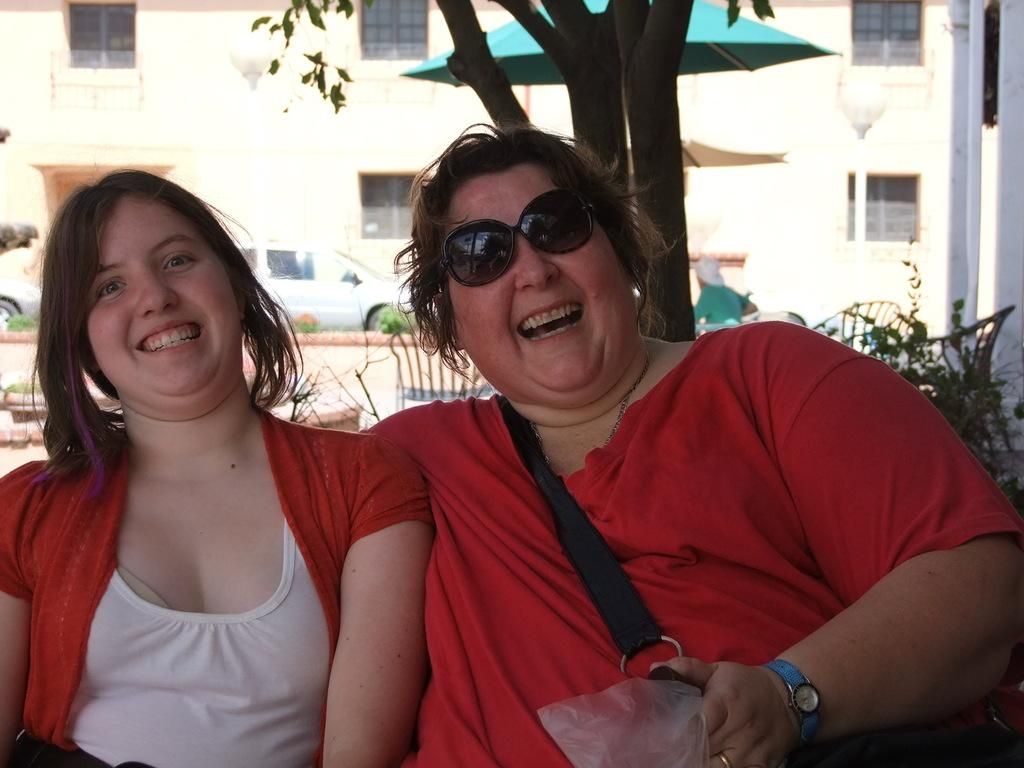Who are the main subjects in the image? There are two ladies in the center of the image. What can be seen at the top side of the image? There is a building and a tree at the top side of the image. What type of oatmeal is being served under the tree in the image? There is no oatmeal or any food item present in the image. What news is being discussed by the ladies in the image? There is no indication of a conversation or news being discussed in the image. 